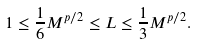Convert formula to latex. <formula><loc_0><loc_0><loc_500><loc_500>1 \leq \frac { 1 } { 6 } M ^ { p / 2 } \leq L \leq \frac { 1 } { 3 } M ^ { p / 2 } .</formula> 